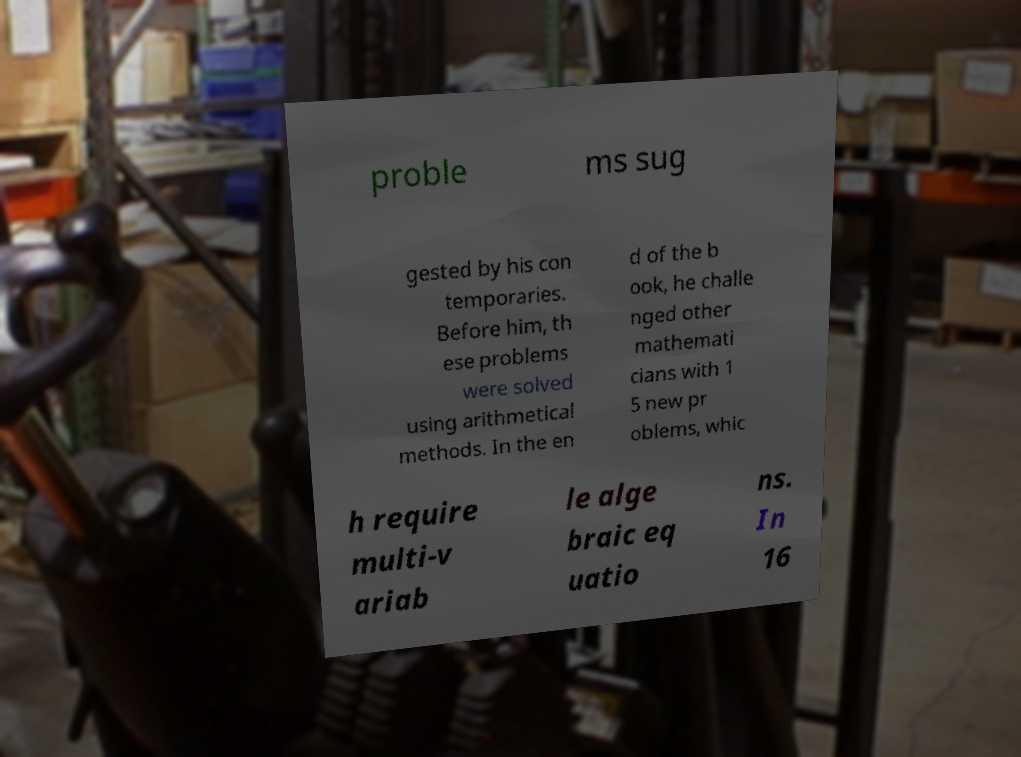Could you extract and type out the text from this image? proble ms sug gested by his con temporaries. Before him, th ese problems were solved using arithmetical methods. In the en d of the b ook, he challe nged other mathemati cians with 1 5 new pr oblems, whic h require multi-v ariab le alge braic eq uatio ns. In 16 